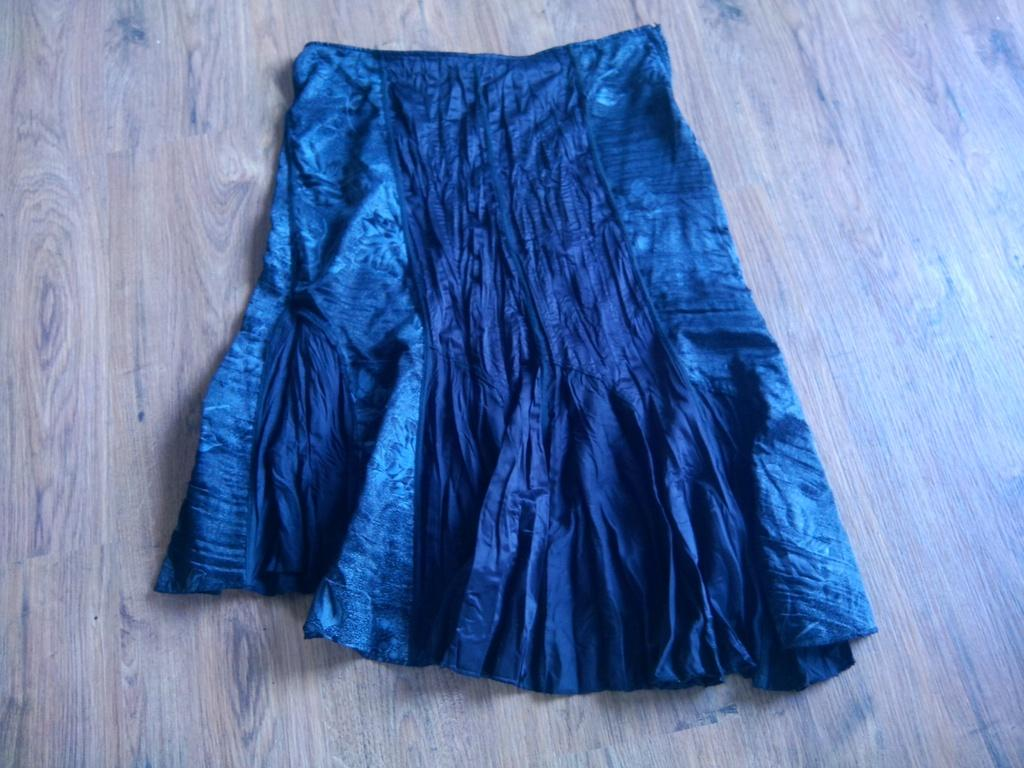What type of clothing is in the image? There is a blue skirt in the image. On what surface is the blue skirt placed? The blue skirt is on a wooden surface. How many dimes are visible on the wooden surface in the image? There are no dimes visible on the wooden surface in the image. What type of net is used to hold the blue skirt in place? There is no net present in the image, and the blue skirt is not held in place by any visible means. 